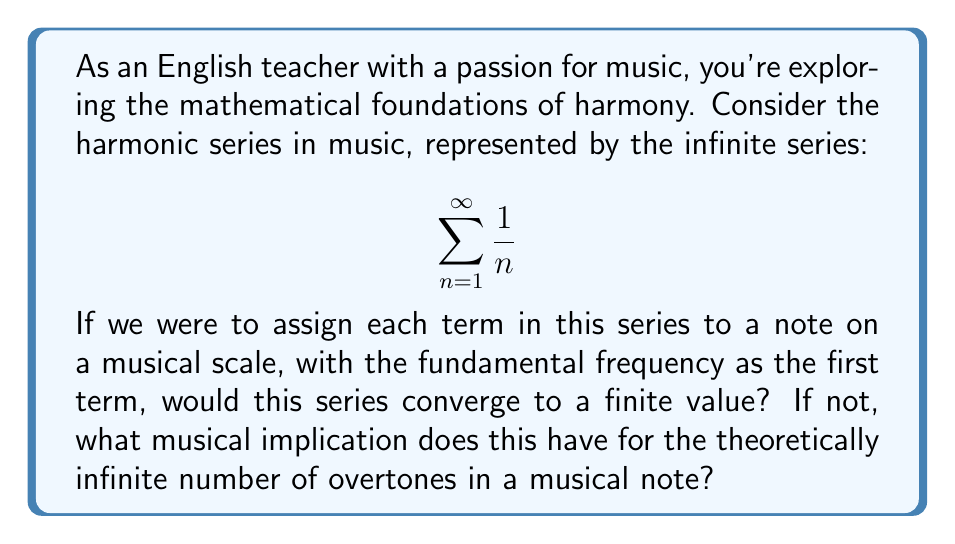Could you help me with this problem? Let's approach this step-by-step:

1) First, we need to determine if the harmonic series converges. We can use the integral test for this.

2) Let $f(x) = \frac{1}{x}$. The integral test compares our series to the integral:

   $$ \int_{1}^{\infty} \frac{1}{x} dx $$

3) Evaluating this integral:

   $$ \int_{1}^{\infty} \frac{1}{x} dx = \lim_{b \to \infty} [\ln|x|]_{1}^{b} = \lim_{b \to \infty} (\ln b - \ln 1) = \infty $$

4) Since the integral diverges to infinity, by the integral test, our original harmonic series also diverges.

5) In musical terms, this means that if we were to assign each term in the harmonic series to a note, we would theoretically have an infinite number of increasingly higher pitched overtones.

6) However, in practice, the amplitude of these overtones decreases as the frequency increases, making higher overtones less audible.

7) This mathematical property aligns with the rich, complex nature of musical tones, where the fundamental frequency is accompanied by a theoretically infinite series of overtones, each contributing to the overall timbre of the sound.

8) The divergence of the series also implies that there's no theoretical upper limit to the frequencies present in a musical note, though physical and perceptual limitations prevent us from hearing the highest overtones.
Answer: The harmonic series diverges, implying an infinite number of overtones in a musical note. 